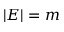<formula> <loc_0><loc_0><loc_500><loc_500>| E | = m</formula> 